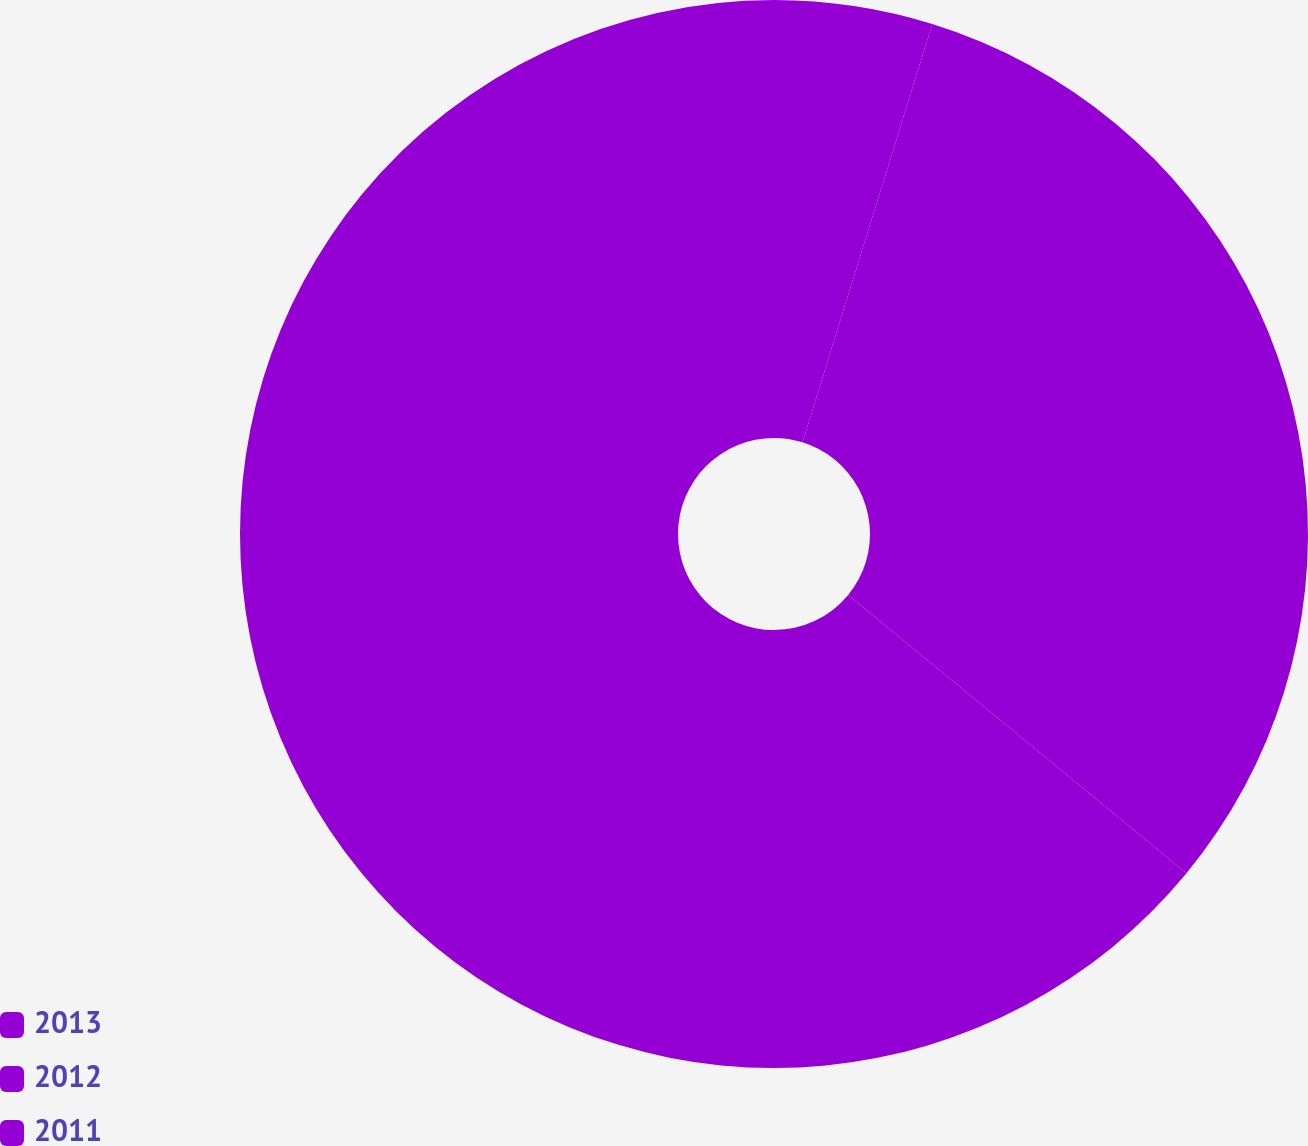Convert chart to OTSL. <chart><loc_0><loc_0><loc_500><loc_500><pie_chart><fcel>2013<fcel>2012<fcel>2011<nl><fcel>4.79%<fcel>31.16%<fcel>64.04%<nl></chart> 